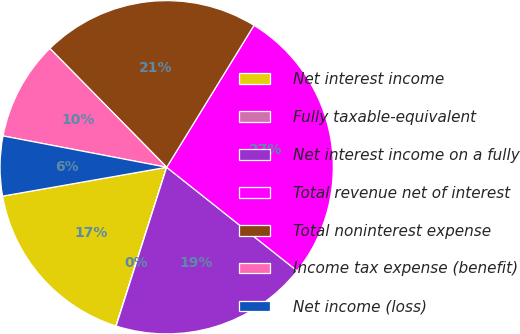<chart> <loc_0><loc_0><loc_500><loc_500><pie_chart><fcel>Net interest income<fcel>Fully taxable-equivalent<fcel>Net interest income on a fully<fcel>Total revenue net of interest<fcel>Total noninterest expense<fcel>Income tax expense (benefit)<fcel>Net income (loss)<nl><fcel>17.3%<fcel>0.02%<fcel>19.22%<fcel>26.9%<fcel>21.14%<fcel>9.62%<fcel>5.78%<nl></chart> 